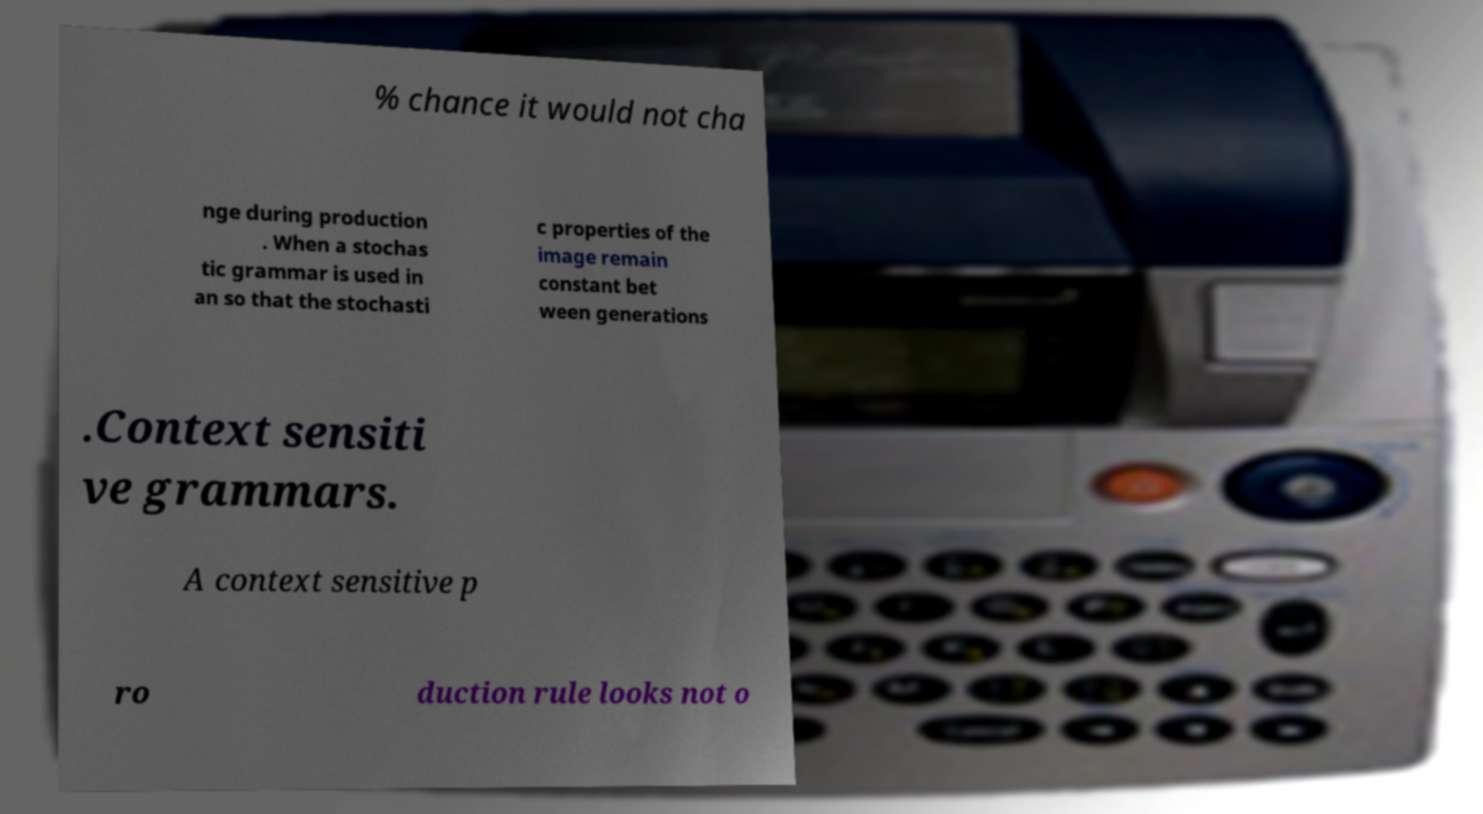I need the written content from this picture converted into text. Can you do that? % chance it would not cha nge during production . When a stochas tic grammar is used in an so that the stochasti c properties of the image remain constant bet ween generations .Context sensiti ve grammars. A context sensitive p ro duction rule looks not o 